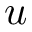Convert formula to latex. <formula><loc_0><loc_0><loc_500><loc_500>u</formula> 